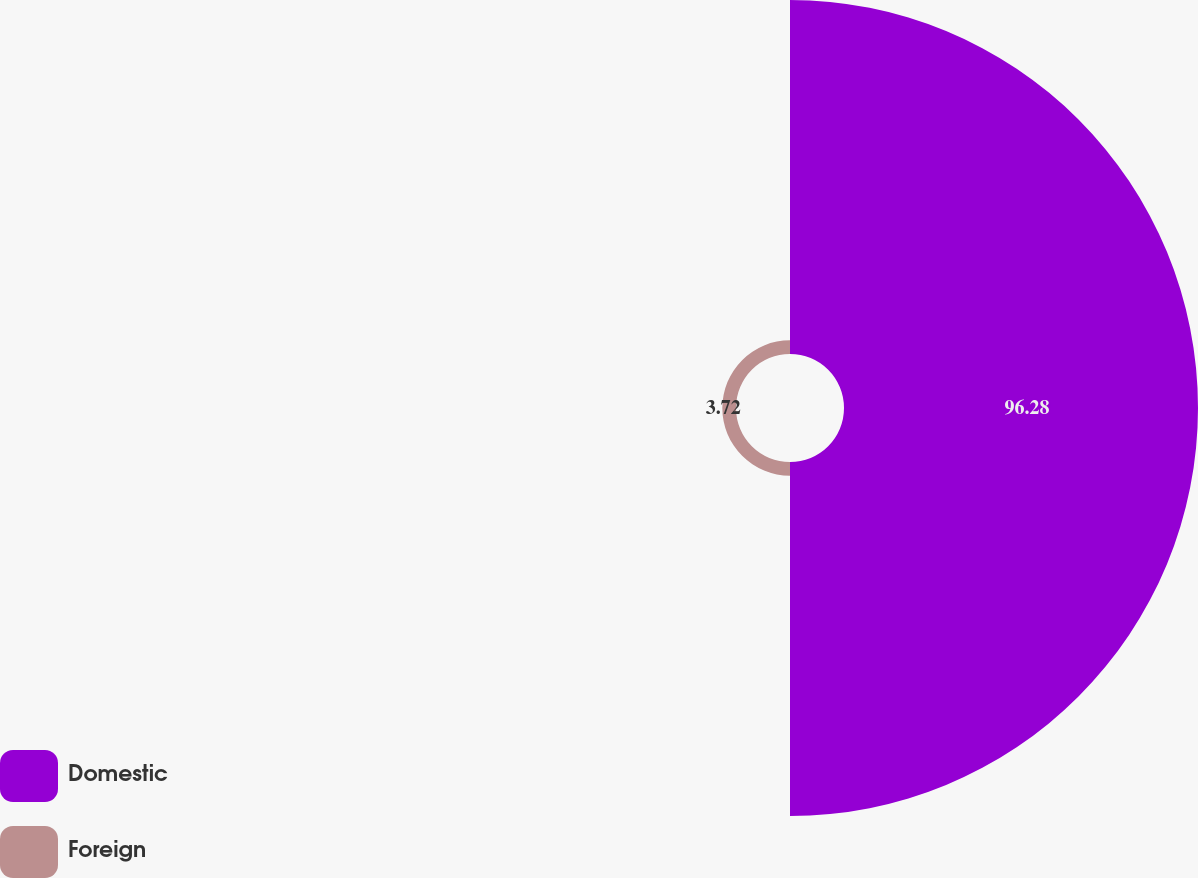Convert chart. <chart><loc_0><loc_0><loc_500><loc_500><pie_chart><fcel>Domestic<fcel>Foreign<nl><fcel>96.28%<fcel>3.72%<nl></chart> 